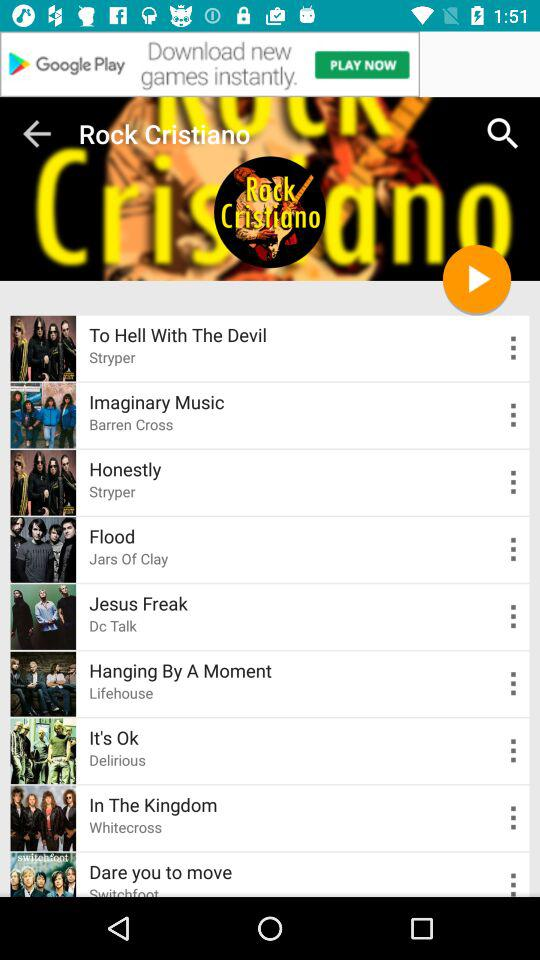Which album does "Flood" belong to? "Flood" belongs to album "Jars Of Clay". 